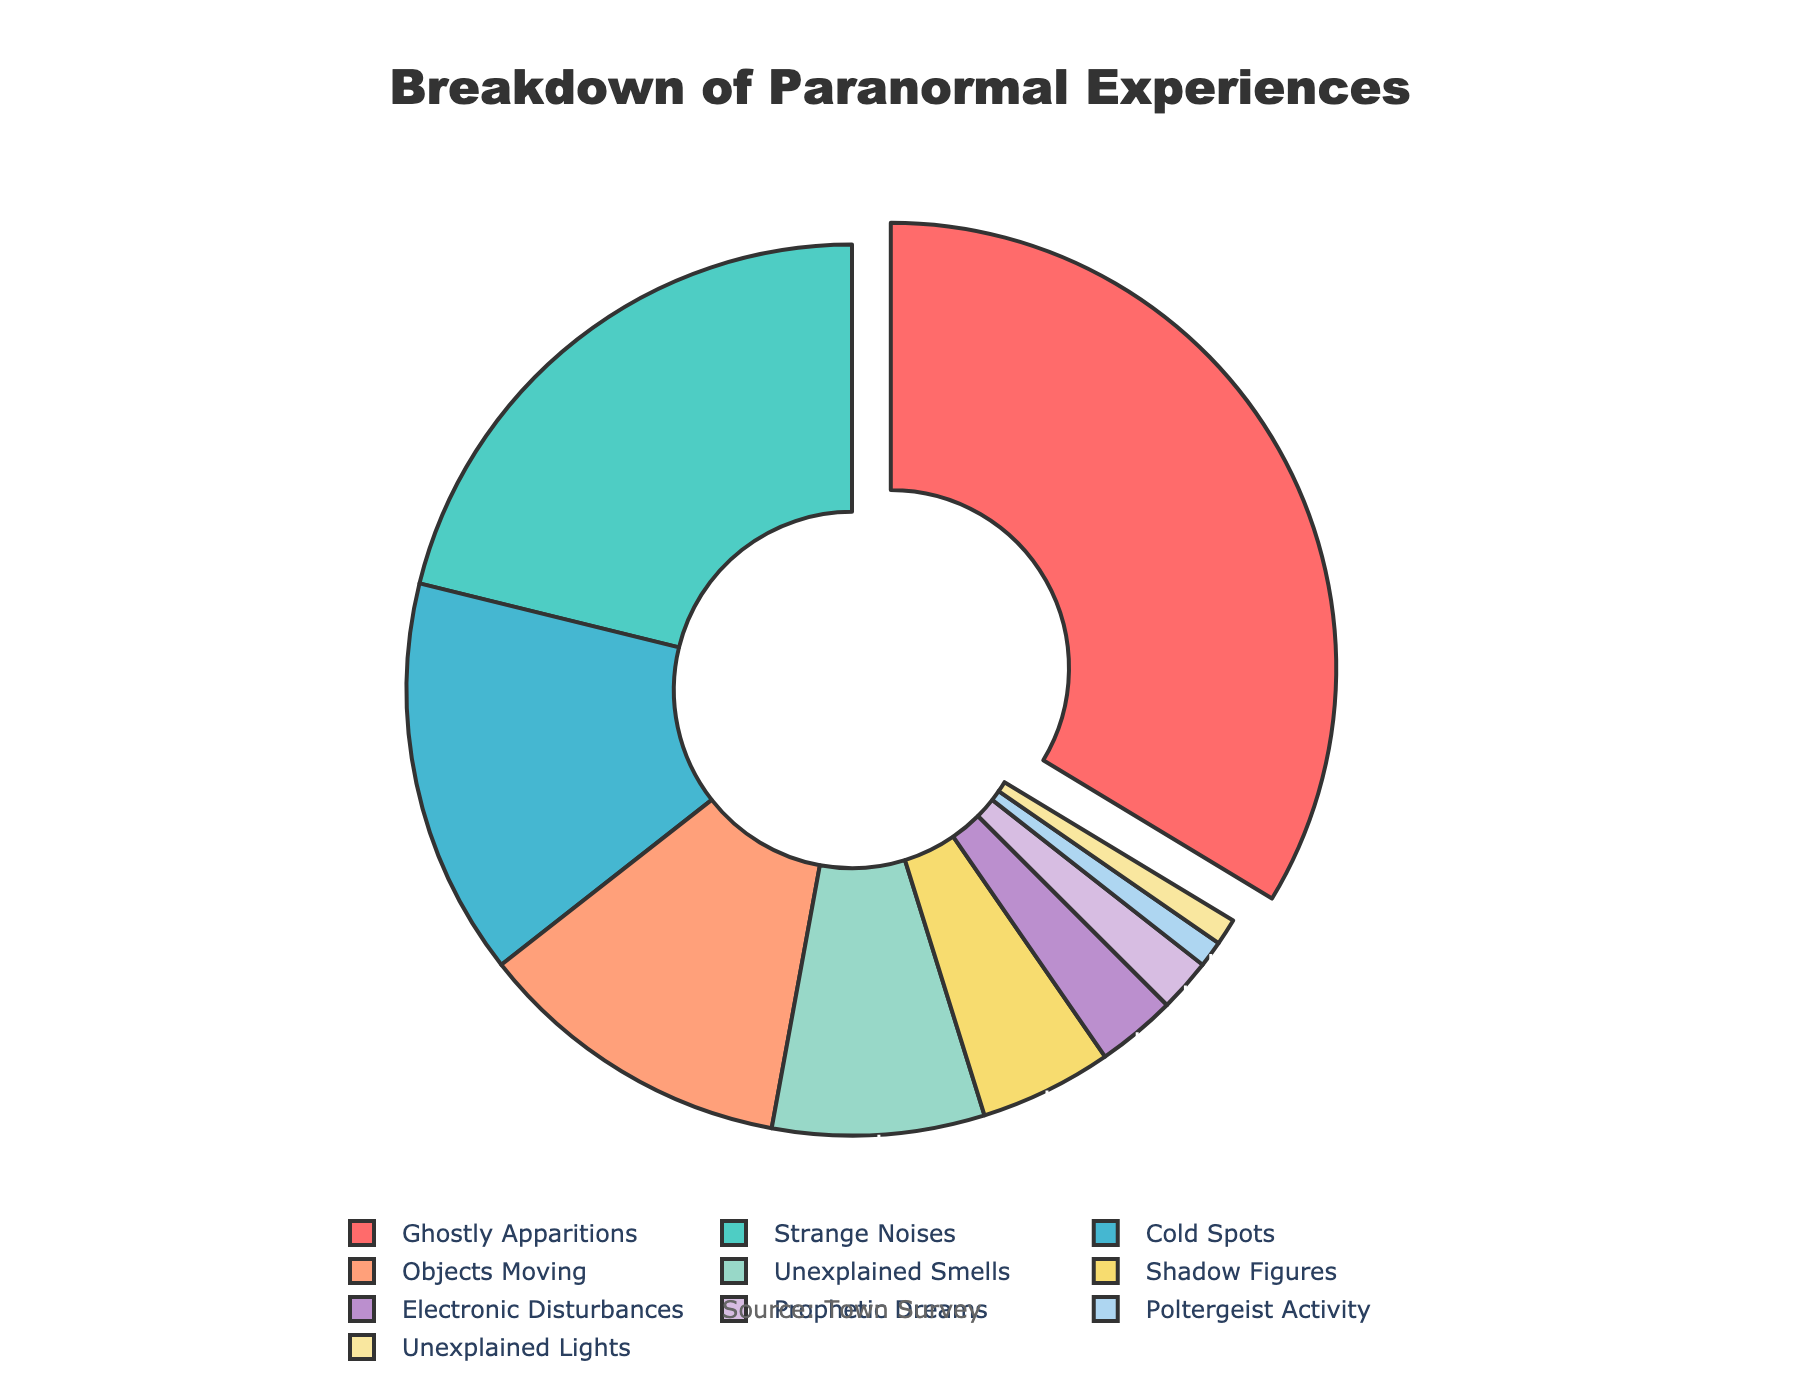what type of paranormal experience is reported the most? Ghostly Apparitions occupy the largest portion of the pie chart, with a percentage of 35%.
Answer: Ghostly Apparitions What types of experiences make up at least half of the total reports combined? Ghostly Apparitions and Strange Noises together make up more than half of the total, with a combined percentage of 35% + 22% = 57%.
Answer: Ghostly Apparitions and Strange Noises What is the least reported type of paranormal experience? Unexplained Lights have the smallest portion in the pie chart, with just 1% of the reports.
Answer: Unexplained Lights How do Cold Spots compare to Electronic Disturbances in terms of percentage? Cold Spots are significantly more reported than Electronic Disturbances, 15% vs. 3%.
Answer: Cold Spots What is the combined percentage of the least reported experiences (those under 5%)? Adding the percentages for Shadow Figures (5%), Electronic Disturbances (3%), Prophetic Dreams (2%), Poltergeist Activity (1%), and Unexplained Lights (1%) yields a total of 5% + 3% + 2% + 1% + 1% = 12%.
Answer: 12% Which types of experiences combined account for less than 10% of the total reports? The experiences that add up to less than 10% are Electronic Disturbances (3%), Prophetic Dreams (2%), Poltergeist Activity (1%), and Unexplained Lights (1%), which combine to 3% + 2% + 1% + 1% = 7%.
Answer: Electronic Disturbances, Prophetic Dreams, Poltergeist Activity, Unexplained Lights How much larger is the percentage of Ghostly Apparitions compared to Objects Moving? The difference in percentages is 35% for Ghostly Apparitions minus 12% for Objects Moving, which is 23%.
Answer: 23% What's the overall percentage represented by the top three types of experiences? Adding the percentages of Ghostly Apparitions (35%), Strange Noises (22%), and Cold Spots (15%) yields a total of 35% + 22% + 15% = 72%.
Answer: 72% Which two types of experiences together have an equal or close to equal percentage to Ghostly Apparitions? The sum of Strange Noises (22%) and Cold Spots (15%) equals 37%, which is very close to 35%.
Answer: Strange Noises and Cold Spots What visual feature highlights the most reported type of paranormal experience in this pie chart? The Ghostly Apparitions segment is visually pulled out from the pie chart, making it stand out.
Answer: Pulled out segment 